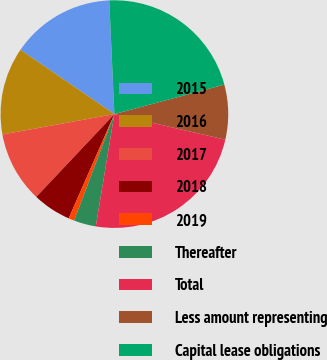Convert chart to OTSL. <chart><loc_0><loc_0><loc_500><loc_500><pie_chart><fcel>2015<fcel>2016<fcel>2017<fcel>2018<fcel>2019<fcel>Thereafter<fcel>Total<fcel>Less amount representing<fcel>Capital lease obligations<nl><fcel>14.73%<fcel>12.42%<fcel>10.1%<fcel>5.46%<fcel>0.82%<fcel>3.14%<fcel>24.01%<fcel>7.78%<fcel>21.55%<nl></chart> 